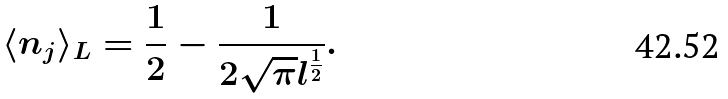<formula> <loc_0><loc_0><loc_500><loc_500>\langle n _ { j } \rangle _ { L } = \frac { 1 } { 2 } - \frac { 1 } { 2 \sqrt { \pi } l ^ { \frac { 1 } { 2 } } } .</formula> 